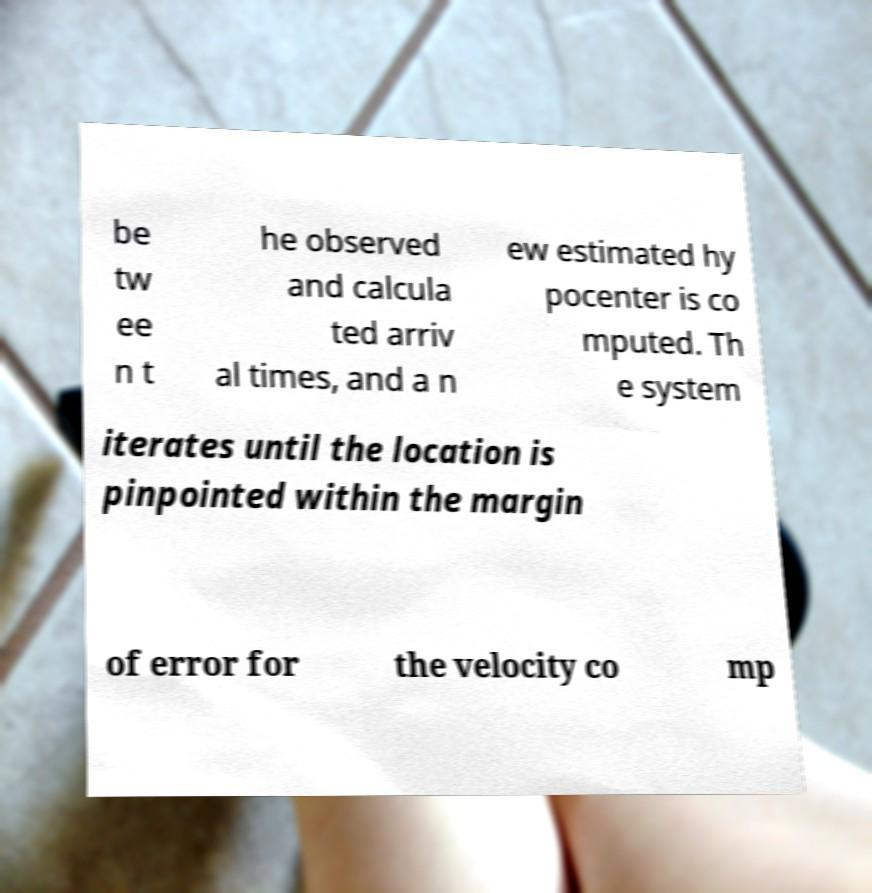Please read and relay the text visible in this image. What does it say? be tw ee n t he observed and calcula ted arriv al times, and a n ew estimated hy pocenter is co mputed. Th e system iterates until the location is pinpointed within the margin of error for the velocity co mp 